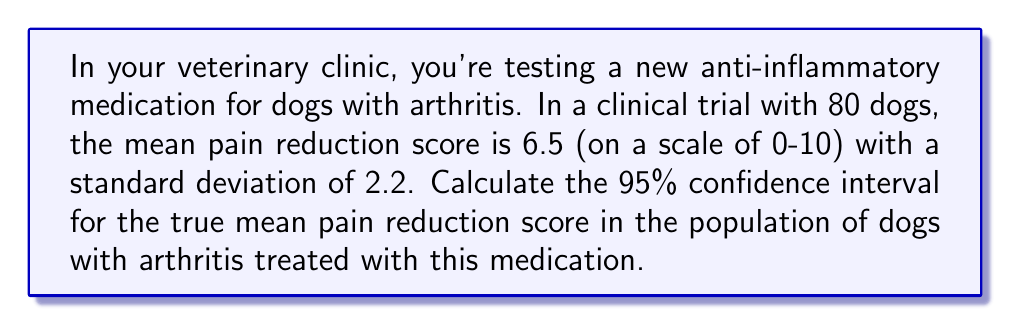Give your solution to this math problem. To calculate the 95% confidence interval, we'll follow these steps:

1) The formula for the confidence interval is:

   $$ \text{CI} = \bar{x} \pm t_{\alpha/2} \cdot \frac{s}{\sqrt{n}} $$

   Where:
   $\bar{x}$ is the sample mean
   $t_{\alpha/2}$ is the t-value for 95% confidence with n-1 degrees of freedom
   $s$ is the sample standard deviation
   $n$ is the sample size

2) We have:
   $\bar{x} = 6.5$
   $s = 2.2$
   $n = 80$
   $\alpha = 0.05$ (for 95% confidence)

3) Degrees of freedom: $df = n - 1 = 80 - 1 = 79$

4) Look up $t_{\alpha/2}$ for 79 df and 95% confidence: $t_{0.025, 79} \approx 1.99$

5) Calculate the margin of error:

   $$ \text{ME} = t_{\alpha/2} \cdot \frac{s}{\sqrt{n}} = 1.99 \cdot \frac{2.2}{\sqrt{80}} \approx 0.488 $$

6) Calculate the confidence interval:

   $$ \text{CI} = 6.5 \pm 0.488 $$

   Lower bound: $6.5 - 0.488 = 6.012$
   Upper bound: $6.5 + 0.488 = 6.988$

Therefore, the 95% confidence interval is (6.012, 6.988).
Answer: (6.012, 6.988) 